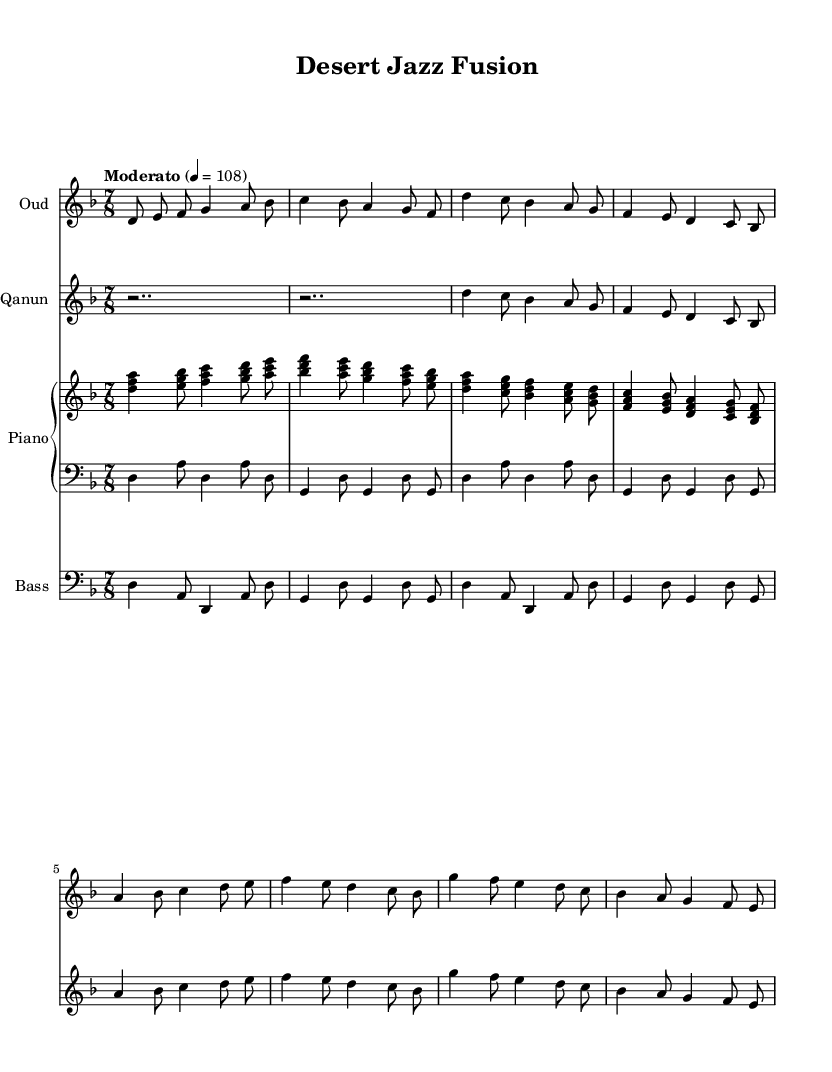What is the key signature of this music? The key signature is found at the beginning of the staff and shows two flats (B flat and E flat). This indicates the music is set in the key of D minor.
Answer: D minor What is the time signature of this music? The time signature is shown as a fraction at the beginning of the score. It displays "7/8", which indicates there are seven beats in each measure and the eighth note gets one beat.
Answer: 7/8 What is the tempo marking for this composition? The tempo marking is indicated at the beginning of the piece, stating "Moderato" followed by a metronome marking of 108. This tells the performer to play at a moderate speed, specifically 108 beats per minute.
Answer: Moderato 4 = 108 How many measures are there in the oud part? By analyzing the oud part, we can count the measures from start to finish. There are a total of 8 measures in the given oud composition.
Answer: 8 measures What is the primary rhythm pattern of the qanun part? The qanun part predominantly uses a pattern alternating between rests and notes primarily in quarter and eighth values, showing an impulsive feel typical of jazz influences. The rhythm maintains a lively character with syncopations.
Answer: Alternating rests and quarter/eighth notes Which instruments are used in this score? The score uses four instruments: Oud, Qanun, Piano (with right hand and left hand parts), and Bass. This ensemble reflects a blend of Middle Eastern and jazz elements.
Answer: Oud, Qanun, Piano, Bass What elements indicate the jazz influence in this composition? The jazz influence can be identified through the rhythmic structure, improvisational feel with syncopations, and the harmonic progressions that move in a style reminiscent of jazz often using seventh chords.
Answer: Syncopation and jazz chords 